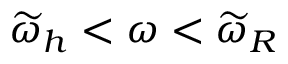Convert formula to latex. <formula><loc_0><loc_0><loc_500><loc_500>\widetilde { \omega } _ { h } < \omega < \widetilde { \omega } _ { R }</formula> 